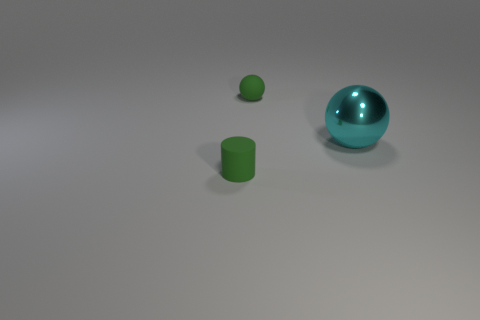Is the number of tiny rubber cylinders greater than the number of purple balls?
Provide a succinct answer. Yes. Do the metal ball and the green matte cylinder have the same size?
Offer a terse response. No. What number of things are tiny red matte cylinders or tiny green matte things?
Offer a very short reply. 2. There is a rubber thing that is on the right side of the small green object that is left of the matte thing that is behind the tiny green rubber cylinder; what shape is it?
Your answer should be very brief. Sphere. Does the tiny green thing that is right of the cylinder have the same material as the tiny green thing that is in front of the cyan metal ball?
Your answer should be compact. Yes. What is the material of the green object that is the same shape as the big cyan object?
Provide a succinct answer. Rubber. Is there anything else that has the same size as the cyan metal object?
Your answer should be very brief. No. Is the shape of the tiny green object that is behind the large cyan metallic ball the same as the object right of the green rubber sphere?
Ensure brevity in your answer.  Yes. Are there fewer small green things that are in front of the tiny green sphere than objects behind the green matte cylinder?
Keep it short and to the point. Yes. What number of other objects are there of the same shape as the cyan metallic thing?
Provide a short and direct response. 1. 